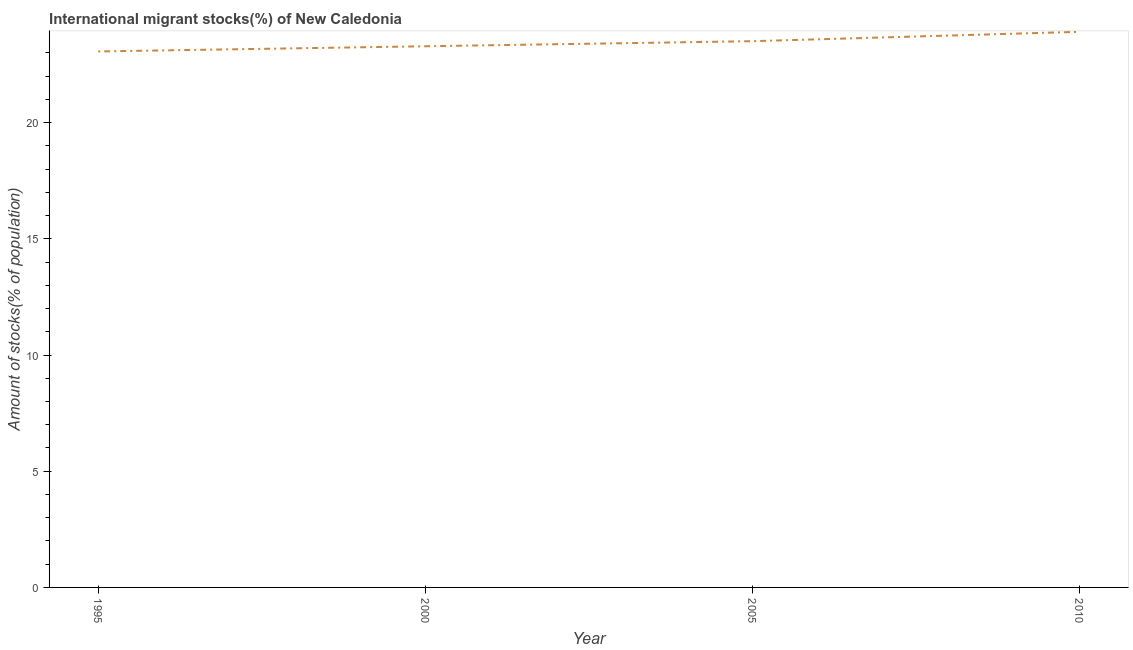What is the number of international migrant stocks in 1995?
Make the answer very short. 23.06. Across all years, what is the maximum number of international migrant stocks?
Provide a succinct answer. 23.91. Across all years, what is the minimum number of international migrant stocks?
Offer a terse response. 23.06. What is the sum of the number of international migrant stocks?
Give a very brief answer. 93.76. What is the difference between the number of international migrant stocks in 2000 and 2010?
Offer a very short reply. -0.62. What is the average number of international migrant stocks per year?
Provide a succinct answer. 23.44. What is the median number of international migrant stocks?
Provide a succinct answer. 23.39. In how many years, is the number of international migrant stocks greater than 3 %?
Your answer should be compact. 4. Do a majority of the years between 2010 and 2005 (inclusive) have number of international migrant stocks greater than 5 %?
Your response must be concise. No. What is the ratio of the number of international migrant stocks in 1995 to that in 2000?
Provide a succinct answer. 0.99. What is the difference between the highest and the second highest number of international migrant stocks?
Keep it short and to the point. 0.4. What is the difference between the highest and the lowest number of international migrant stocks?
Ensure brevity in your answer.  0.85. In how many years, is the number of international migrant stocks greater than the average number of international migrant stocks taken over all years?
Give a very brief answer. 2. Does the number of international migrant stocks monotonically increase over the years?
Your response must be concise. Yes. What is the difference between two consecutive major ticks on the Y-axis?
Keep it short and to the point. 5. Are the values on the major ticks of Y-axis written in scientific E-notation?
Offer a terse response. No. Does the graph contain grids?
Offer a terse response. No. What is the title of the graph?
Your response must be concise. International migrant stocks(%) of New Caledonia. What is the label or title of the X-axis?
Make the answer very short. Year. What is the label or title of the Y-axis?
Ensure brevity in your answer.  Amount of stocks(% of population). What is the Amount of stocks(% of population) of 1995?
Keep it short and to the point. 23.06. What is the Amount of stocks(% of population) in 2000?
Your answer should be compact. 23.29. What is the Amount of stocks(% of population) in 2005?
Provide a succinct answer. 23.5. What is the Amount of stocks(% of population) of 2010?
Offer a very short reply. 23.91. What is the difference between the Amount of stocks(% of population) in 1995 and 2000?
Offer a very short reply. -0.22. What is the difference between the Amount of stocks(% of population) in 1995 and 2005?
Provide a short and direct response. -0.44. What is the difference between the Amount of stocks(% of population) in 1995 and 2010?
Give a very brief answer. -0.85. What is the difference between the Amount of stocks(% of population) in 2000 and 2005?
Your answer should be compact. -0.22. What is the difference between the Amount of stocks(% of population) in 2000 and 2010?
Provide a short and direct response. -0.62. What is the difference between the Amount of stocks(% of population) in 2005 and 2010?
Your answer should be very brief. -0.4. What is the ratio of the Amount of stocks(% of population) in 1995 to that in 2010?
Keep it short and to the point. 0.96. What is the ratio of the Amount of stocks(% of population) in 2000 to that in 2005?
Give a very brief answer. 0.99. What is the ratio of the Amount of stocks(% of population) in 2000 to that in 2010?
Your response must be concise. 0.97. 